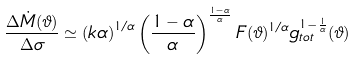<formula> <loc_0><loc_0><loc_500><loc_500>\frac { \Delta \dot { M } ( \vartheta ) } { \Delta \sigma } \simeq \left ( k \alpha \right ) ^ { 1 / \alpha } \left ( \frac { 1 - \alpha } { \alpha } \right ) ^ { \frac { 1 - \alpha } { \alpha } } F ( \vartheta ) ^ { 1 / \alpha } g _ { t o t } ^ { 1 - \frac { 1 } { \alpha } } ( \vartheta )</formula> 